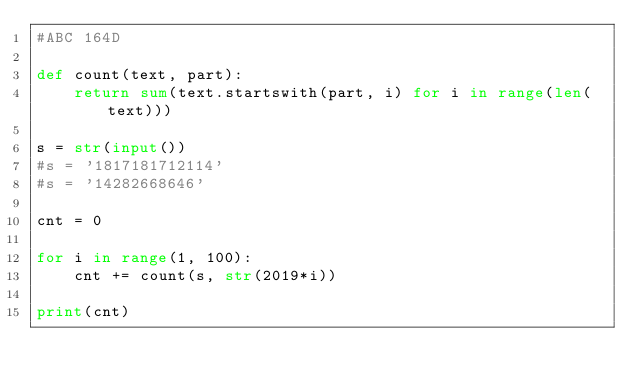<code> <loc_0><loc_0><loc_500><loc_500><_Python_>#ABC 164D

def count(text, part):
    return sum(text.startswith(part, i) for i in range(len(text)))

s = str(input())
#s = '1817181712114'
#s = '14282668646'

cnt = 0

for i in range(1, 100):
    cnt += count(s, str(2019*i))

print(cnt)</code> 